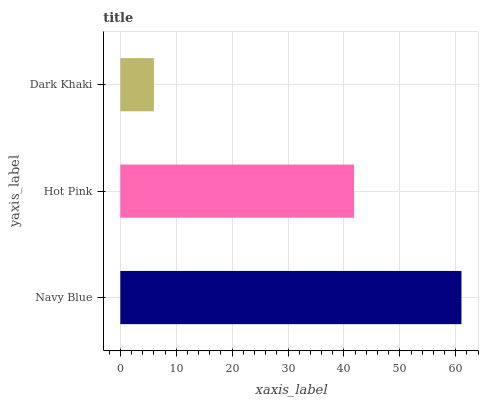Is Dark Khaki the minimum?
Answer yes or no. Yes. Is Navy Blue the maximum?
Answer yes or no. Yes. Is Hot Pink the minimum?
Answer yes or no. No. Is Hot Pink the maximum?
Answer yes or no. No. Is Navy Blue greater than Hot Pink?
Answer yes or no. Yes. Is Hot Pink less than Navy Blue?
Answer yes or no. Yes. Is Hot Pink greater than Navy Blue?
Answer yes or no. No. Is Navy Blue less than Hot Pink?
Answer yes or no. No. Is Hot Pink the high median?
Answer yes or no. Yes. Is Hot Pink the low median?
Answer yes or no. Yes. Is Navy Blue the high median?
Answer yes or no. No. Is Navy Blue the low median?
Answer yes or no. No. 